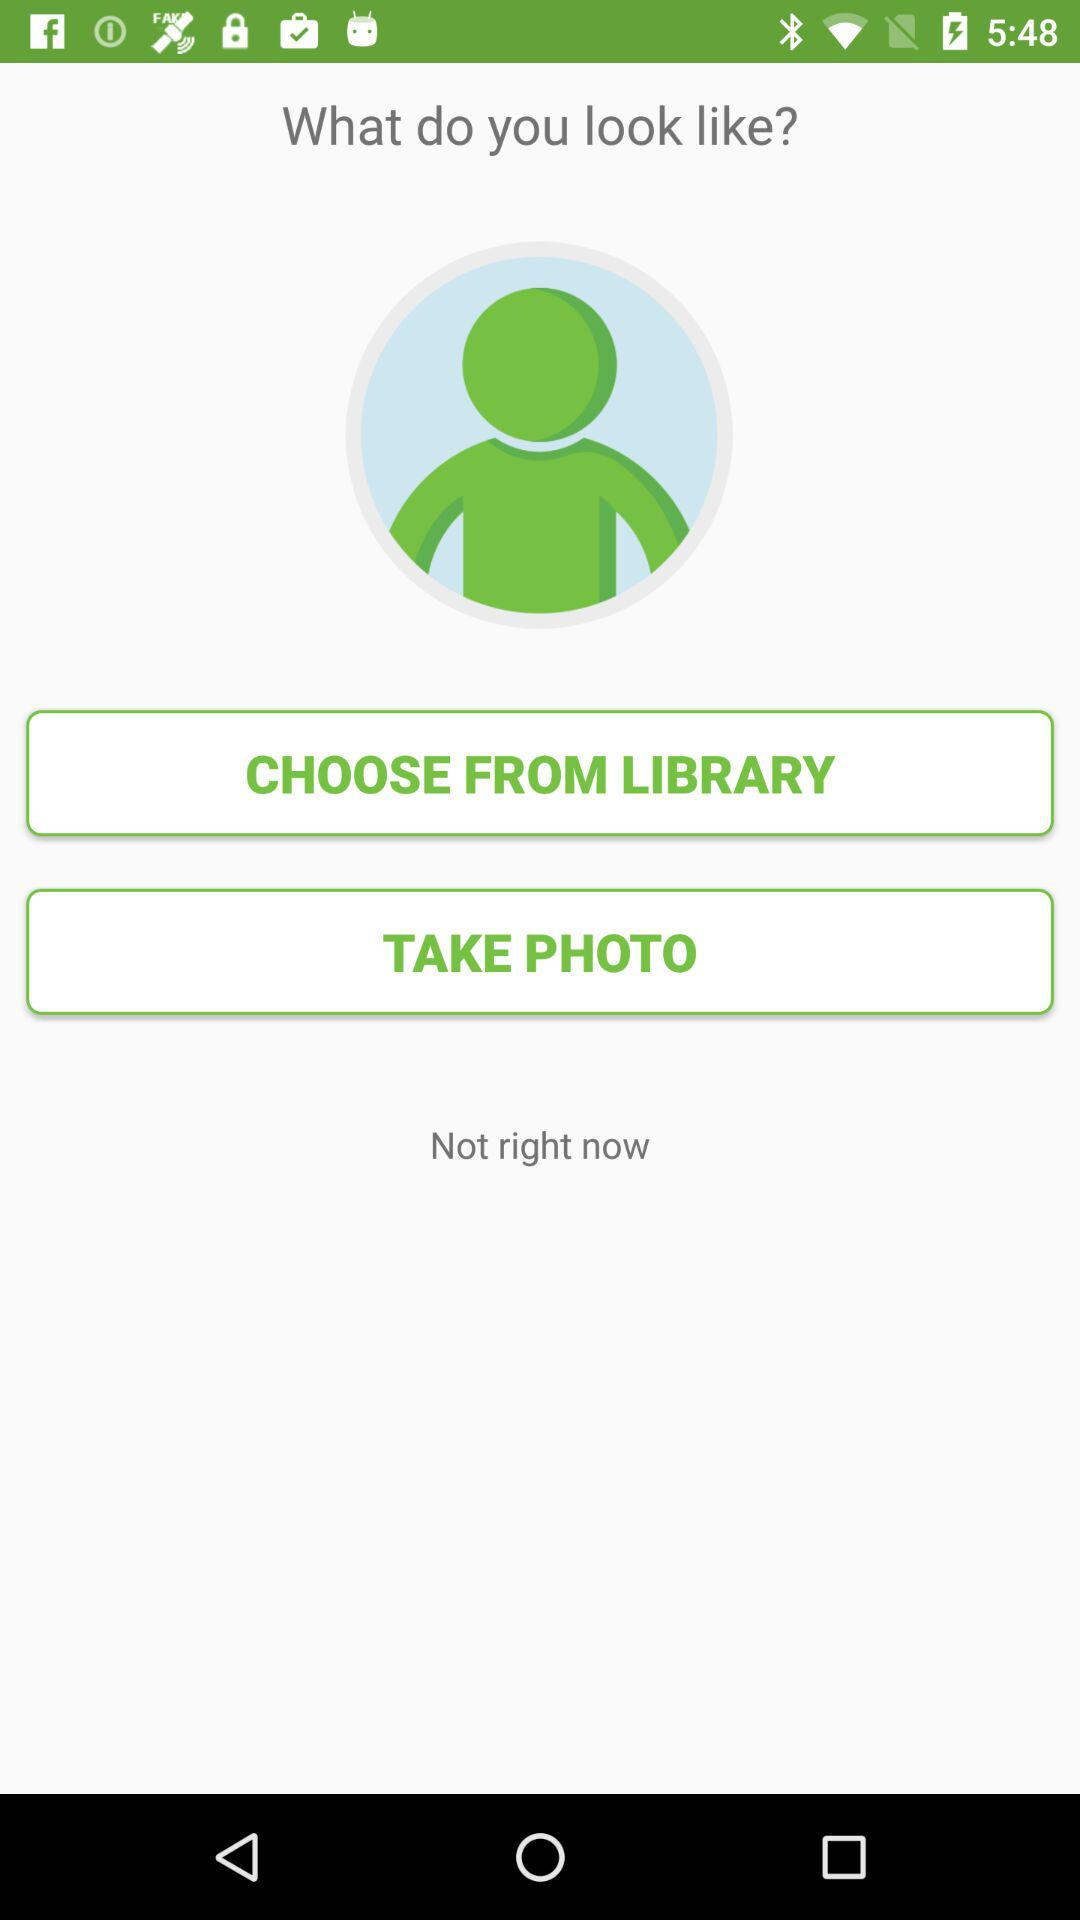How many ways can I select a photo to show the assistant?
Answer the question using a single word or phrase. 2 